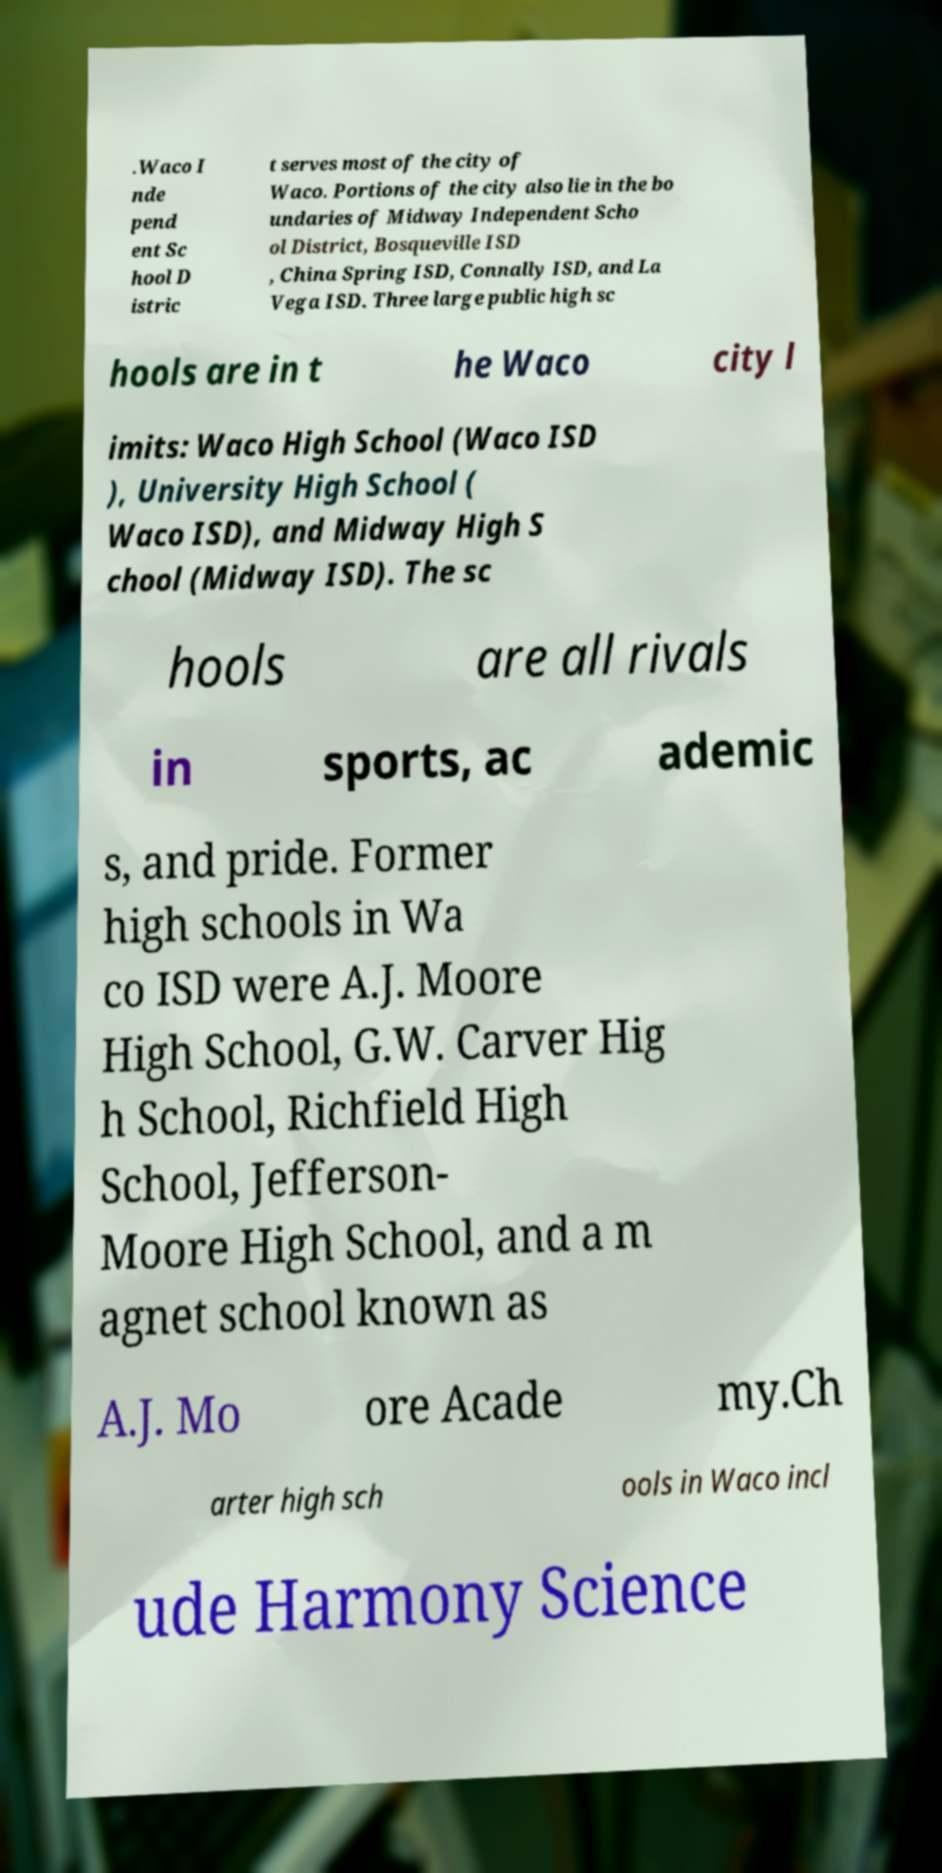Could you extract and type out the text from this image? .Waco I nde pend ent Sc hool D istric t serves most of the city of Waco. Portions of the city also lie in the bo undaries of Midway Independent Scho ol District, Bosqueville ISD , China Spring ISD, Connally ISD, and La Vega ISD. Three large public high sc hools are in t he Waco city l imits: Waco High School (Waco ISD ), University High School ( Waco ISD), and Midway High S chool (Midway ISD). The sc hools are all rivals in sports, ac ademic s, and pride. Former high schools in Wa co ISD were A.J. Moore High School, G.W. Carver Hig h School, Richfield High School, Jefferson- Moore High School, and a m agnet school known as A.J. Mo ore Acade my.Ch arter high sch ools in Waco incl ude Harmony Science 